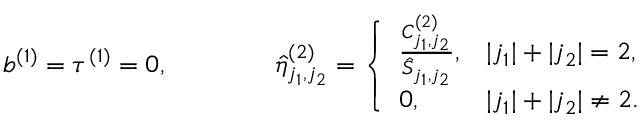<formula> <loc_0><loc_0><loc_500><loc_500>b ^ { ( 1 ) } = \tau ^ { ( 1 ) } = 0 , \quad \hat { \eta } _ { j _ { 1 } , j _ { 2 } } ^ { ( 2 ) } = \left \{ \begin{array} { l l } { \frac { C _ { j _ { 1 } , j _ { 2 } } ^ { ( 2 ) } } { \hat { S } _ { j _ { 1 } , j _ { 2 } } } , } & { | j _ { 1 } | + | j _ { 2 } | = 2 , } \\ { 0 , } & { | j _ { 1 } | + | j _ { 2 } | \neq 2 . } \end{array}</formula> 